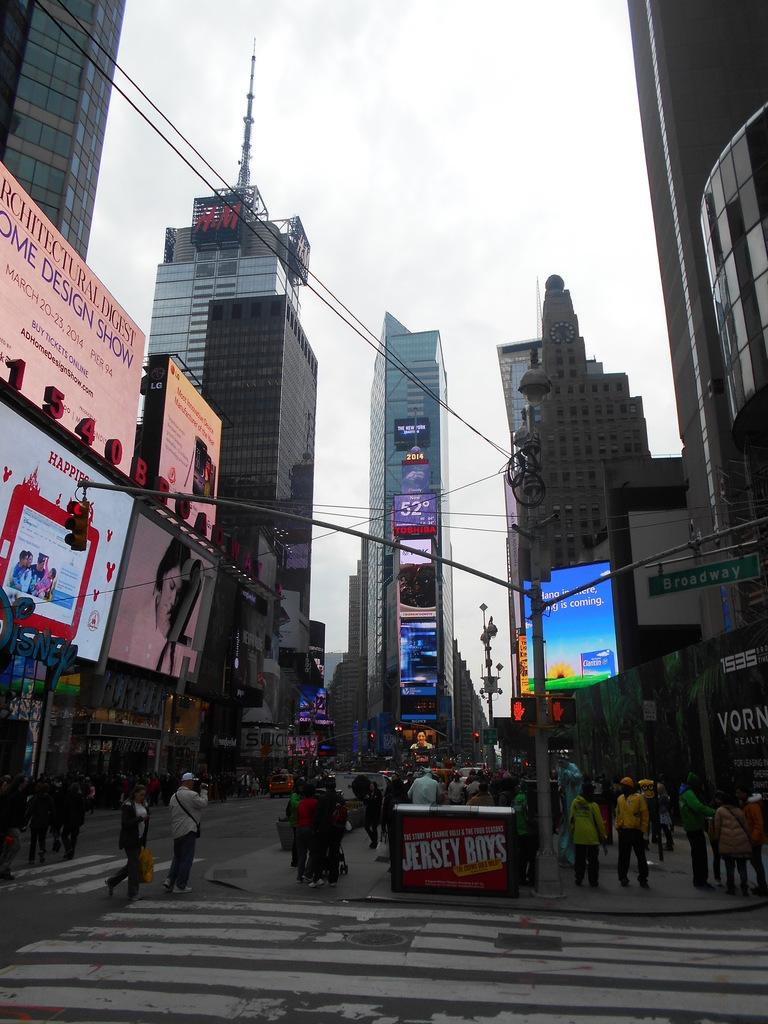What is happening in the image? There is a group of people standing in the image. What objects can be seen in the image besides the people? There are poles, lights, buildings, and screens in the image. What is visible in the background of the image? The sky is visible in the background of the image. What type of apparatus is being used for the distribution of water in the image? There is no apparatus for water distribution present in the image. Can you see a tub in the image? There is no tub present in the image. 